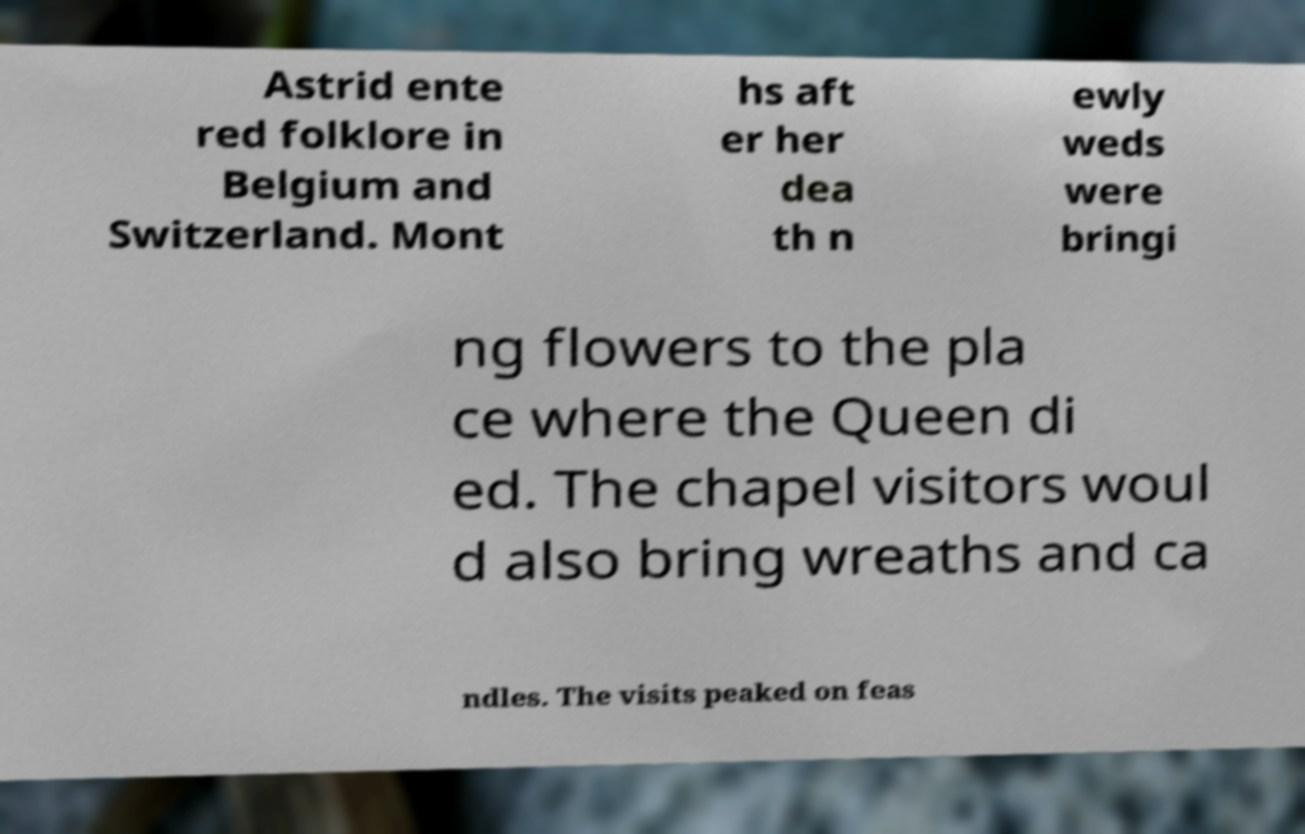What messages or text are displayed in this image? I need them in a readable, typed format. Astrid ente red folklore in Belgium and Switzerland. Mont hs aft er her dea th n ewly weds were bringi ng flowers to the pla ce where the Queen di ed. The chapel visitors woul d also bring wreaths and ca ndles. The visits peaked on feas 